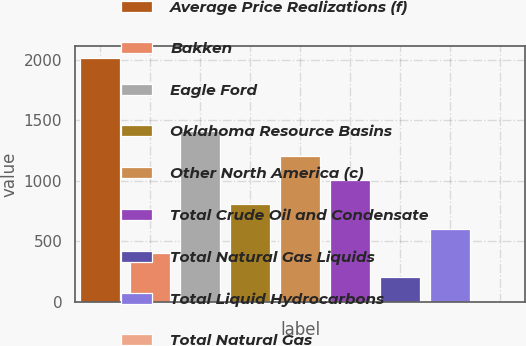<chart> <loc_0><loc_0><loc_500><loc_500><bar_chart><fcel>Average Price Realizations (f)<fcel>Bakken<fcel>Eagle Ford<fcel>Oklahoma Resource Basins<fcel>Other North America (c)<fcel>Total Crude Oil and Condensate<fcel>Total Natural Gas Liquids<fcel>Total Liquid Hydrocarbons<fcel>Total Natural Gas<nl><fcel>2012<fcel>405.54<fcel>1409.59<fcel>807.16<fcel>1208.78<fcel>1007.97<fcel>204.73<fcel>606.35<fcel>3.92<nl></chart> 